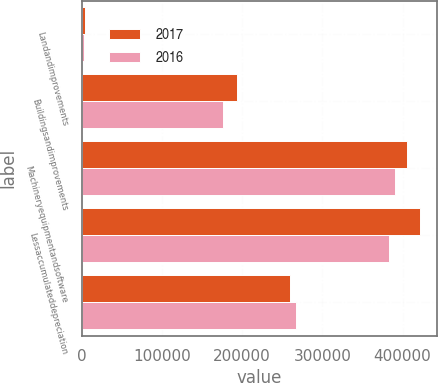<chart> <loc_0><loc_0><loc_500><loc_500><stacked_bar_chart><ecel><fcel>Landandimprovements<fcel>Buildingsandimprovements<fcel>Machineryequipmentandsoftware<fcel>Lessaccumulateddepreciation<fcel>Unnamed: 5<nl><fcel>2017<fcel>3350<fcel>193940<fcel>405209<fcel>422052<fcel>259710<nl><fcel>2016<fcel>3096<fcel>175684<fcel>390720<fcel>383713<fcel>267398<nl></chart> 